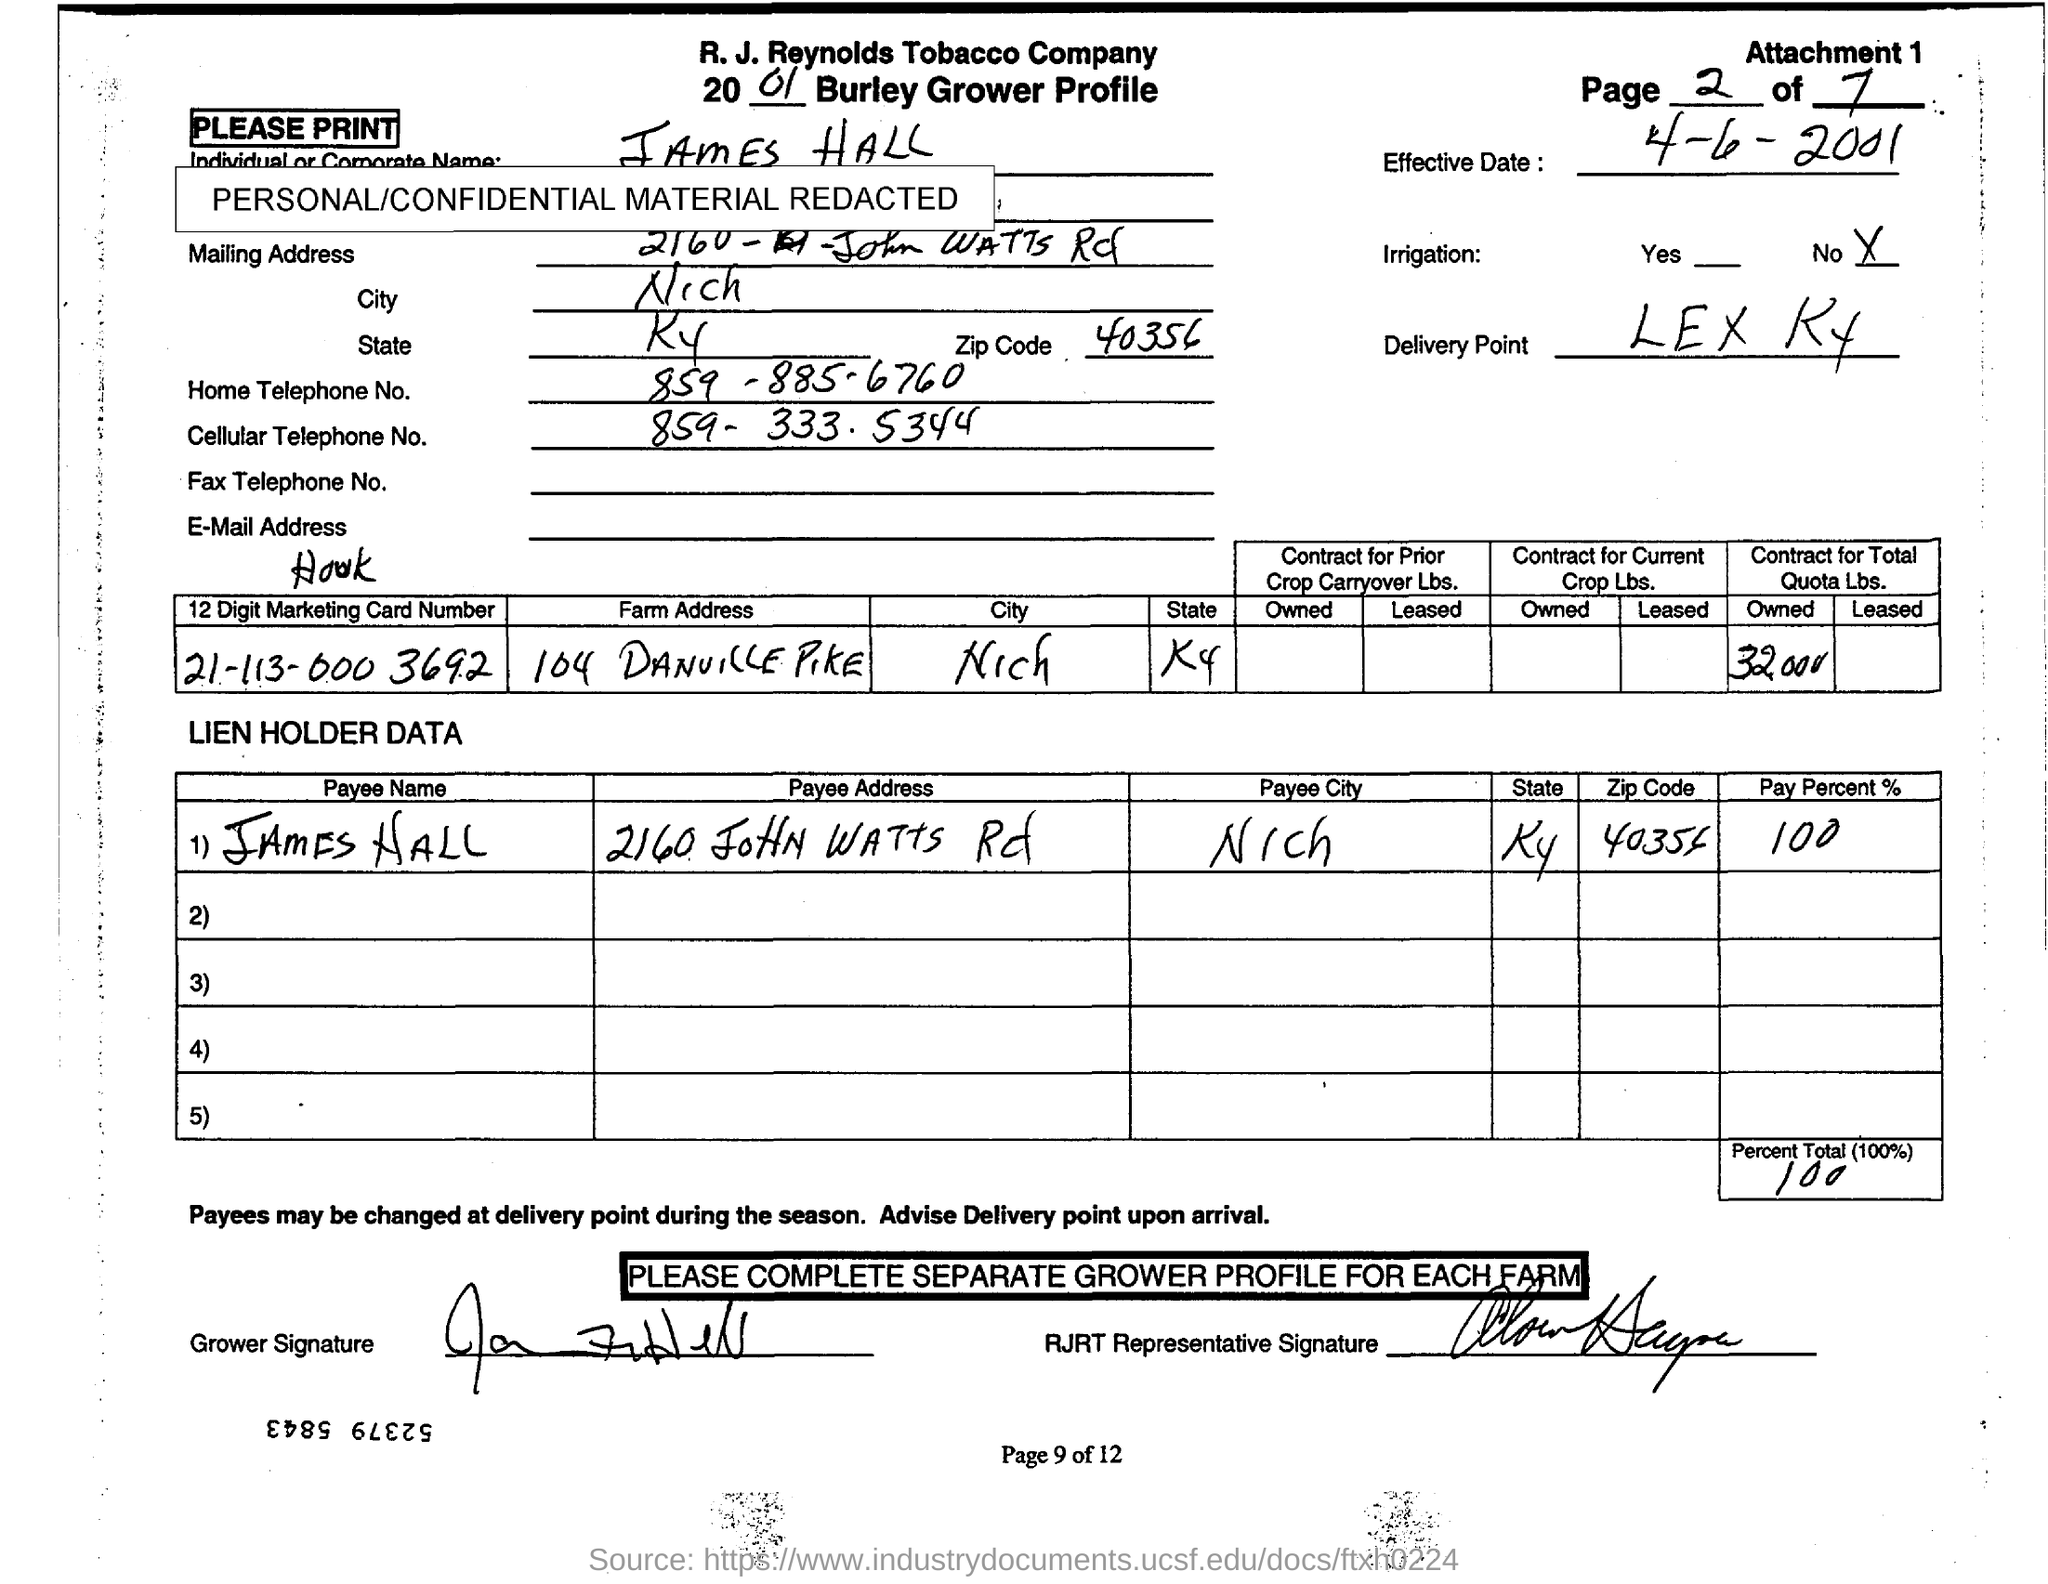Draw attention to some important aspects in this diagram. The question "What is the home telephone number of James Hall?" is asking for the individual's contact information, specifically their home telephone number. The telephone number provided is 859-885-6760. The payment reference number written as "Payee City" in the second table is "Nicholson The name of the person whose name is written in the "Payee Name" column of the second table is James Hall. The first table contains the '12 Digit Marketing Card Number' in the first column, which is written as 21-113-000 3692. How much is the "Percent Total (100%)" value? It is 100%. 